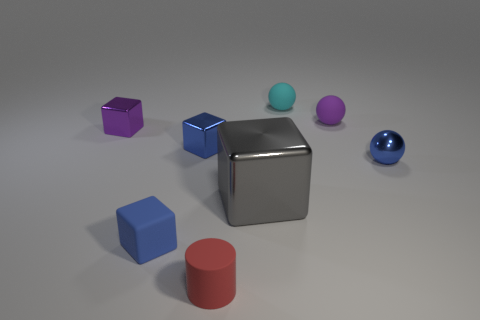Subtract all tiny matte spheres. How many spheres are left? 1 Add 2 purple rubber cubes. How many objects exist? 10 Subtract all cylinders. How many objects are left? 7 Subtract all gray blocks. How many blocks are left? 3 Subtract 1 blue spheres. How many objects are left? 7 Subtract 1 cylinders. How many cylinders are left? 0 Subtract all brown balls. Subtract all green cylinders. How many balls are left? 3 Subtract all cyan cylinders. How many blue spheres are left? 1 Subtract all blue shiny blocks. Subtract all blocks. How many objects are left? 3 Add 3 metal things. How many metal things are left? 7 